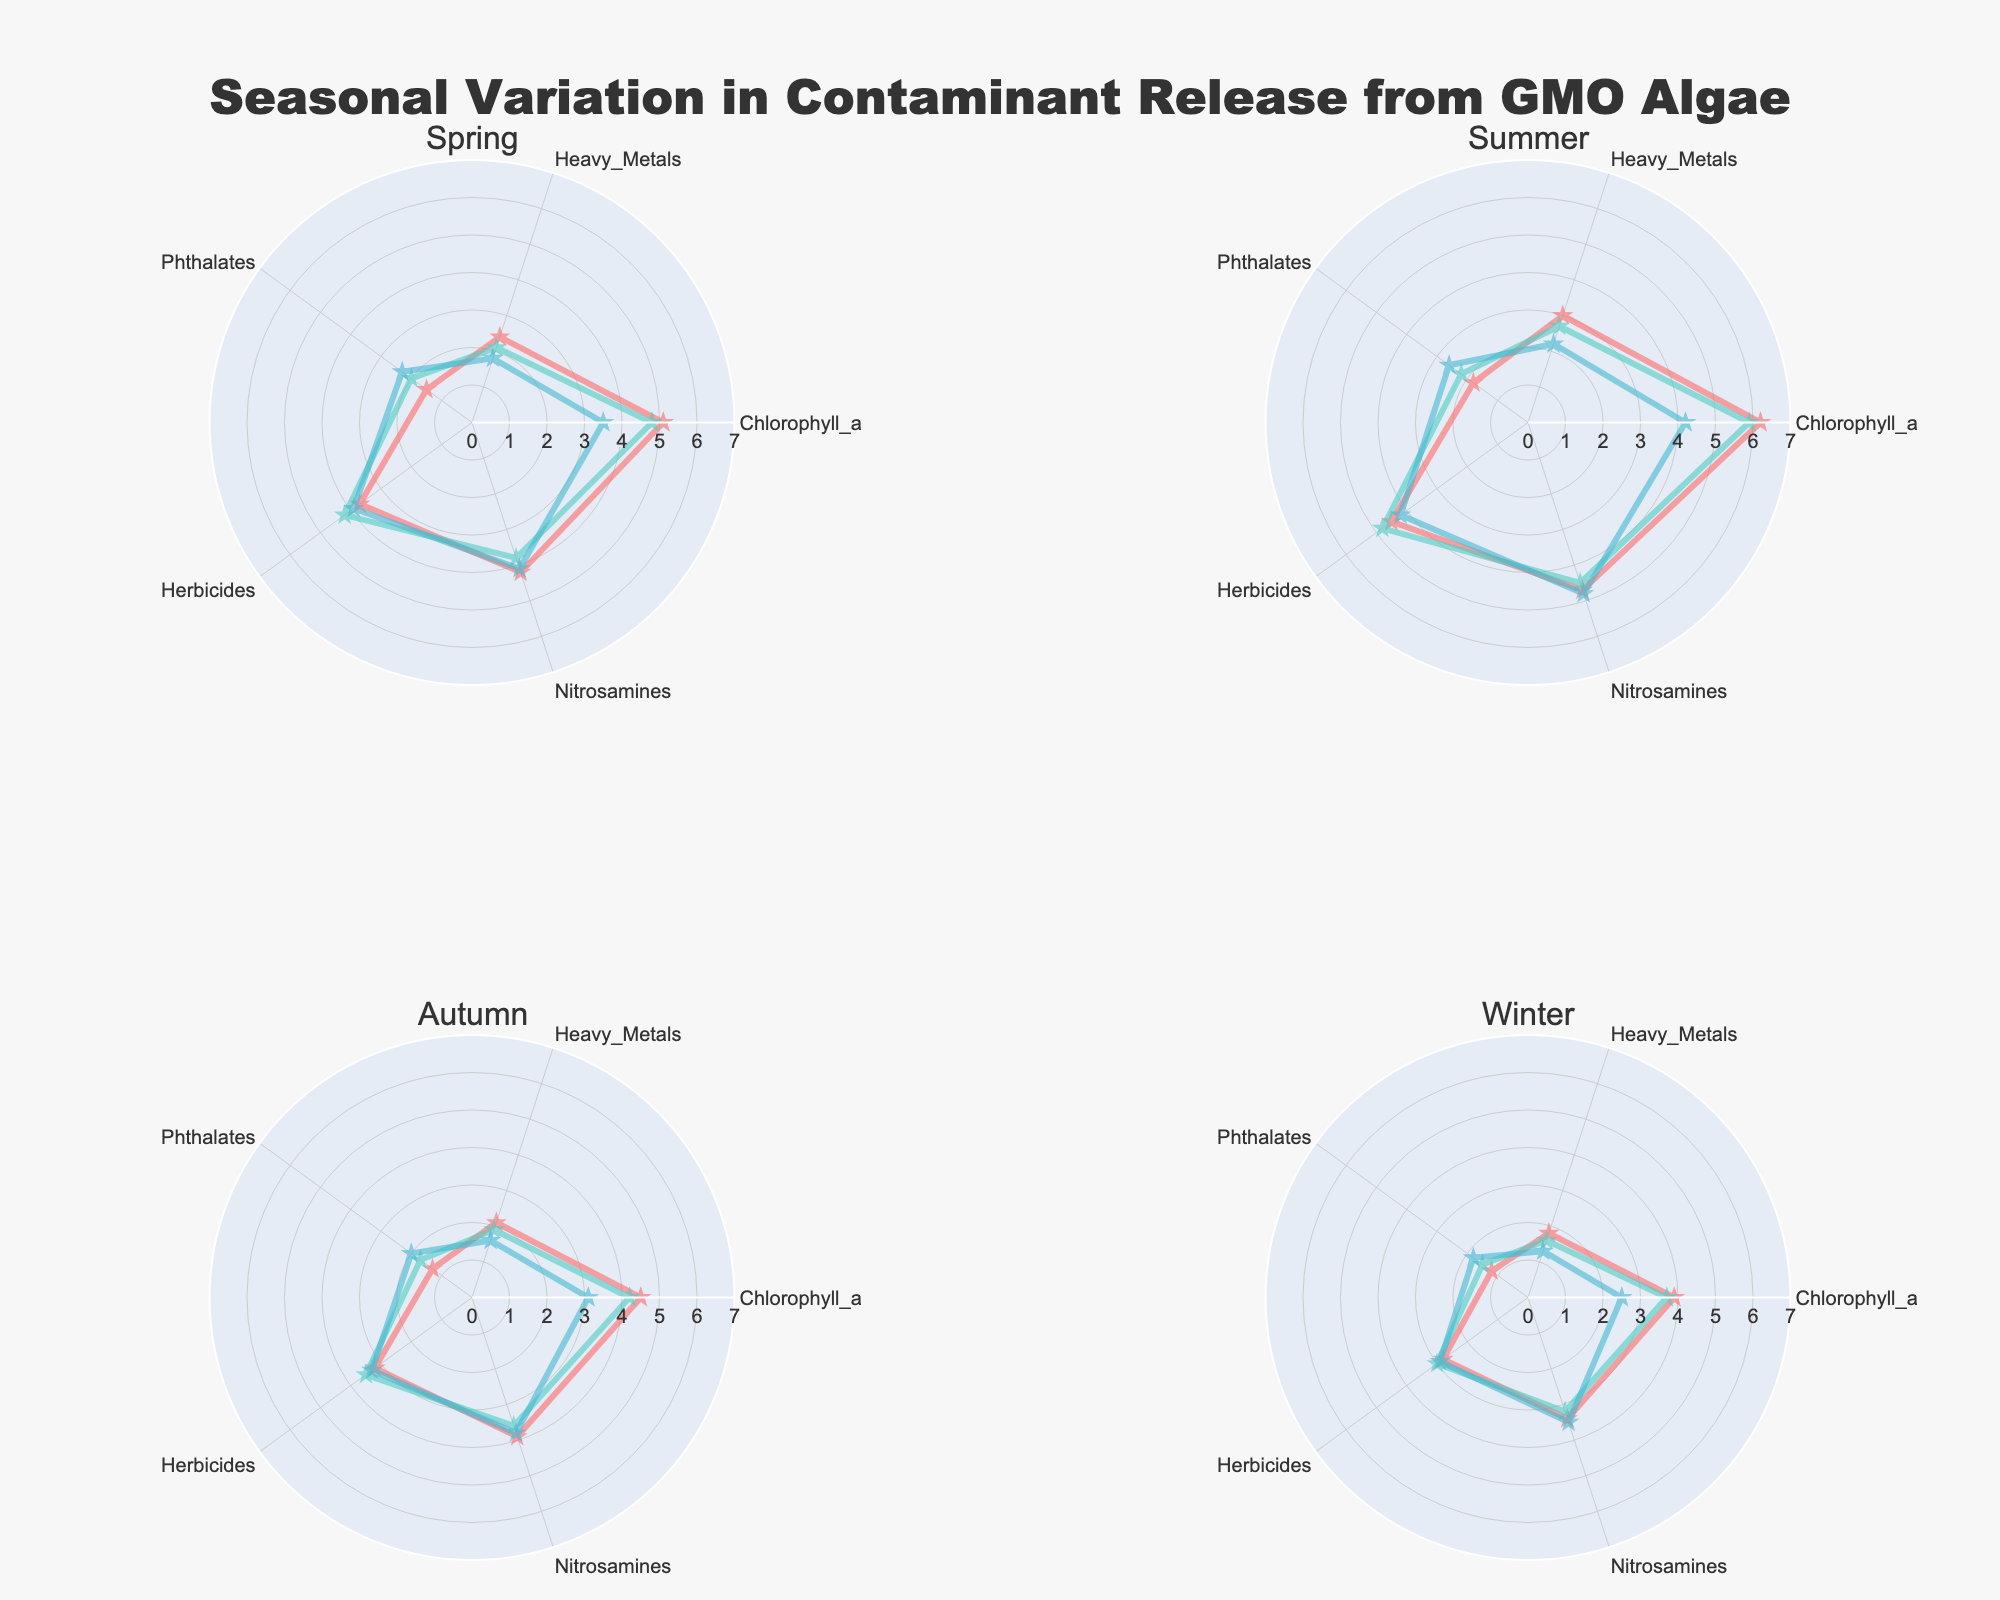How many seasons are represented in the figure? The title of each subplot denotes a different season. By counting these titles, you can determine the number of seasons.
Answer: 4 Which contaminant has the highest Chlorophyll_a value in Summer? By inspecting the radar chart for Summer, look at the Chlorophyll_a axis and compare the lengths of the lines representing Copper, Zinc, and Lead. The longest line indicates the highest value.
Answer: Copper What is the difference in Heavy Metals value for Copper between Spring and Autumn? Examine the Heavy Metals axis on the radar charts for both Spring and Autumn. Find the values for Copper and calculate the difference: 2.4 (Spring) - 2.1 (Autumn) = 0.3.
Answer: 0.3 Which season shows the lowest Phthalates level for the contaminant Zinc? Check the Phthalates axis across the subplots and compare the values of Zinc in each season. The lowest value will be the answer.
Answer: Winter In which season is the Nitrosamines value for Lead the highest? Look at the Nitrosamines axis for each season and compare the values for Lead. The season with the highest value will be the correct answer.
Answer: Summer What is the average Chlorophyll_a value for Lead across all seasons? Add the Chlorophyll_a values for Lead for each season: 3.5 (Spring) + 4.2 (Summer) + 3.1 (Autumn) + 2.5 (Winter) = 13.3. Divide this by the number of seasons, which is 4: 13.3 / 4 = 3.325.
Answer: 3.325 Compare the Herbicides values for Copper and Lead in Winter. Which is higher? Locate the Herbicides axis on the Winter subplot. Compare the values for Copper and Lead. The longer line on the axis indicates the higher value.
Answer: Copper Which season has the most balanced values for Copper across all variables? For each season’s radar chart, visually assess how evenly the values of Copper spread around the radar chart. The closer the values are to each other, the more balanced it is.
Answer: Autumn 